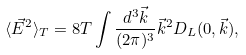Convert formula to latex. <formula><loc_0><loc_0><loc_500><loc_500>\langle \vec { E } ^ { 2 } \rangle _ { T } = 8 T \int \frac { d ^ { 3 } \vec { k } } { ( 2 \pi ) ^ { 3 } } \vec { k } ^ { 2 } D _ { L } ( 0 , \vec { k } ) ,</formula> 